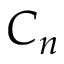<formula> <loc_0><loc_0><loc_500><loc_500>C _ { n }</formula> 